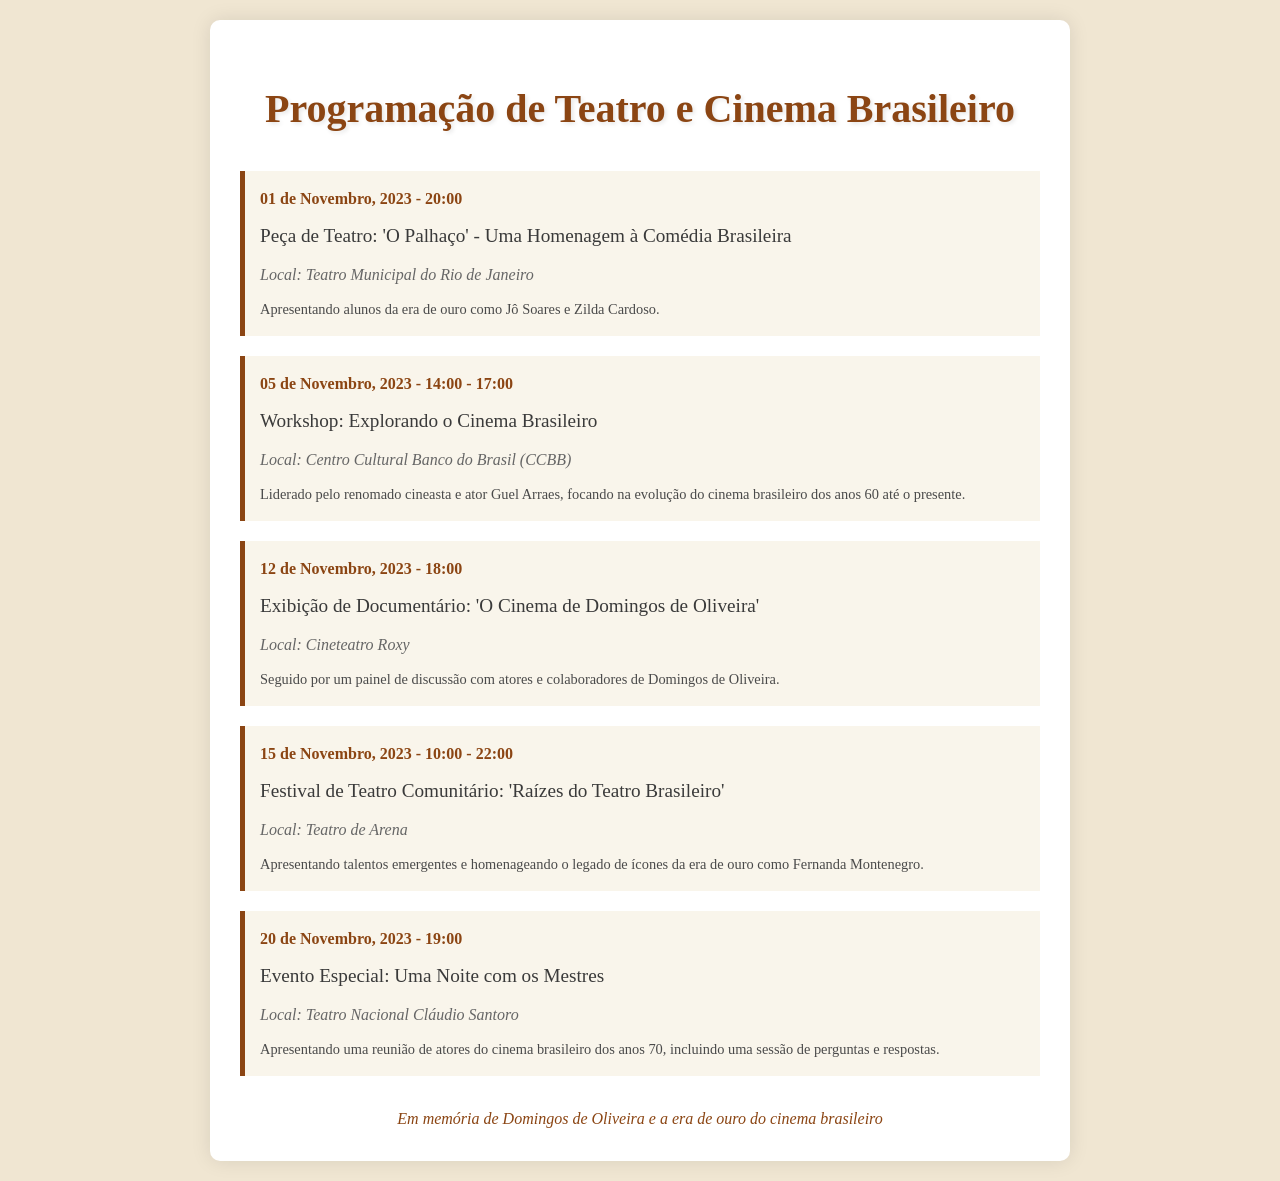what is the title of the theater play on November 1st? The title is found in the event details of the document for the date November 1st.
Answer: 'O Palhaço' - Uma Homenagem à Comédia Brasileira who is leading the workshop on November 5th? The information is included in the note of the November 5th event, specifically mentioning the facilitator's name.
Answer: Guel Arraes what time does the community theater festival start on November 15th? The starting time is stated at the beginning of the event description for November 15th.
Answer: 10:00 which venue is hosting the documentary screening on November 12th? The location of the screening is detailed in the event specifics for that date.
Answer: Cineteatro Roxy what is the main theme of the event on November 20th? The theme or focus of the event is indicated in the event note for that date.
Answer: Uma Noite com os Mestres how many hours is the workshop on November 5th? The duration can be calculated from the start and end times given in the event description.
Answer: 3 horas 